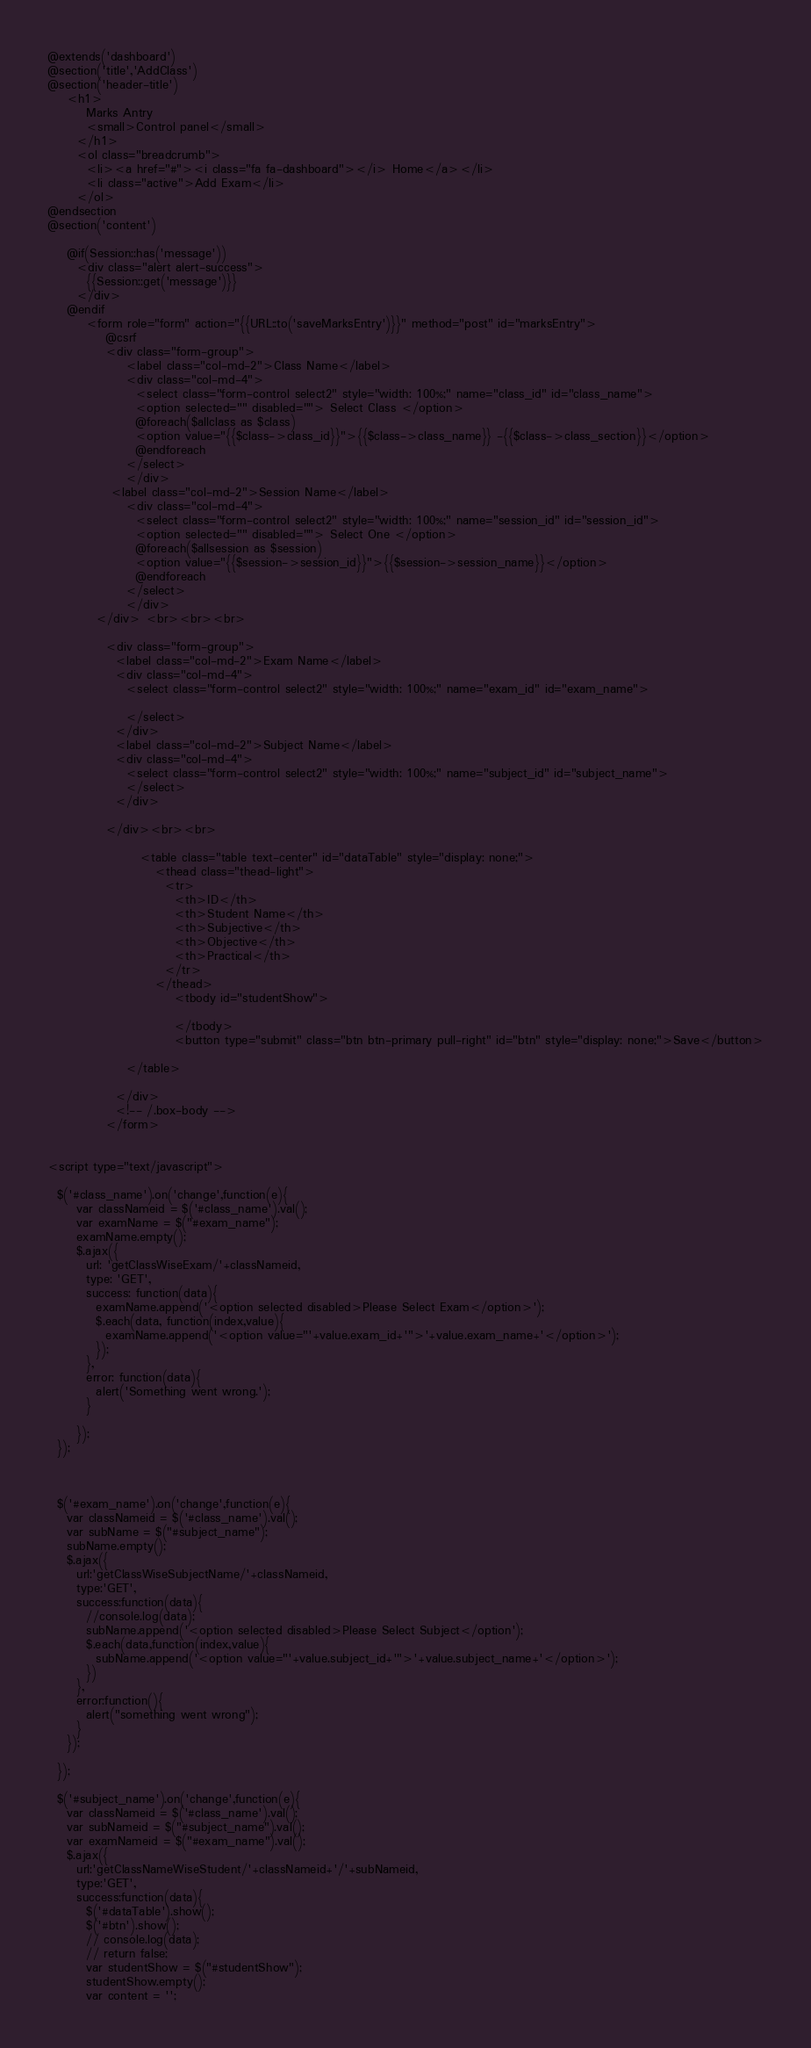Convert code to text. <code><loc_0><loc_0><loc_500><loc_500><_PHP_>@extends('dashboard')
@section('title','AddClass')
@section('header-title')
	<h1>
        Marks Antry
        <small>Control panel</small>
      </h1>
      <ol class="breadcrumb">
        <li><a href="#"><i class="fa fa-dashboard"></i> Home</a></li>
        <li class="active">Add Exam</li>
      </ol>
@endsection    
@section('content')
	
    @if(Session::has('message'))
      <div class="alert alert-success">
        {{Session::get('message')}}
      </div>
    @endif
		<form role="form" action="{{URL::to('saveMarksEntry')}}" method="post" id="marksEntry">
			@csrf 
            <div class="form-group">
                <label class="col-md-2">Class Name</label>
                <div class="col-md-4">
                  <select class="form-control select2" style="width: 100%;" name="class_id" id="class_name">
                  <option selected="" disabled=""> Select Class </option>
                  @foreach($allclass as $class)
                  <option value="{{$class->class_id}}">{{$class->class_name}} -{{$class->class_section}}</option>
                  @endforeach
                </select>
                </div>
             <label class="col-md-2">Session Name</label>
                <div class="col-md-4">
                  <select class="form-control select2" style="width: 100%;" name="session_id" id="session_id">
                  <option selected="" disabled=""> Select One </option>
                  @foreach($allsession as $session)
                  <option value="{{$session->session_id}}">{{$session->session_name}}</option>
                  @endforeach
                </select>
                </div>
          </div> <br><br><br>
            
            <div class="form-group">
              <label class="col-md-2">Exam Name</label>
              <div class="col-md-4">
                <select class="form-control select2" style="width: 100%;" name="exam_id" id="exam_name">
                
                </select>
              </div>
              <label class="col-md-2">Subject Name</label>
              <div class="col-md-4">
                <select class="form-control select2" style="width: 100%;" name="subject_id" id="subject_name">
                </select>
              </div>
              
            </div><br><br>
                
                   <table class="table text-center" id="dataTable" style="display: none;">
                      <thead class="thead-light">
                        <tr>
                          <th>ID</th>
                          <th>Student Name</th>
                          <th>Subjective</th>
                          <th>Objective</th>
                          <th>Practical</th>
                        </tr>
                      </thead>
                          <tbody id="studentShow">
                           
                          </tbody>
                          <button type="submit" class="btn btn-primary pull-right" id="btn" style="display: none;">Save</button>
                
                </table>

              </div>
              <!-- /.box-body -->
            </form>


<script type="text/javascript">

  $('#class_name').on('change',function(e){
      var classNameid = $('#class_name').val();
      var examName = $("#exam_name");
      examName.empty();
      $.ajax({
        url: 'getClassWiseExam/'+classNameid,
        type: 'GET',
        success: function(data){
          examName.append('<option selected disabled>Please Select Exam</option>');
          $.each(data, function(index,value){
            examName.append('<option value="'+value.exam_id+'">'+value.exam_name+'</option>');
          });
        },
        error: function(data){
          alert('Something went wrong.');
        }

      });
  });



  $('#exam_name').on('change',function(e){
    var classNameid = $('#class_name').val();
    var subName = $("#subject_name");
    subName.empty();
    $.ajax({
      url:'getClassWiseSubjectName/'+classNameid,
      type:'GET',
      success:function(data){
        //console.log(data);
        subName.append('<option selected disabled>Please Select Subject</option');
        $.each(data,function(index,value){
          subName.append('<option value="'+value.subject_id+'">'+value.subject_name+'</option>');
        })
      },
      error:function(){
        alert("something went wrong");
      }
    });

  });

  $('#subject_name').on('change',function(e){
    var classNameid = $('#class_name').val();
    var subNameid = $("#subject_name").val();
    var examNameid = $("#exam_name").val();
    $.ajax({
      url:'getClassNameWiseStudent/'+classNameid+'/'+subNameid,
      type:'GET',
      success:function(data){
        $('#dataTable').show();
        $('#btn').show();
        // console.log(data);
        // return false;
        var studentShow = $("#studentShow");
        studentShow.empty();
        var content = '';</code> 